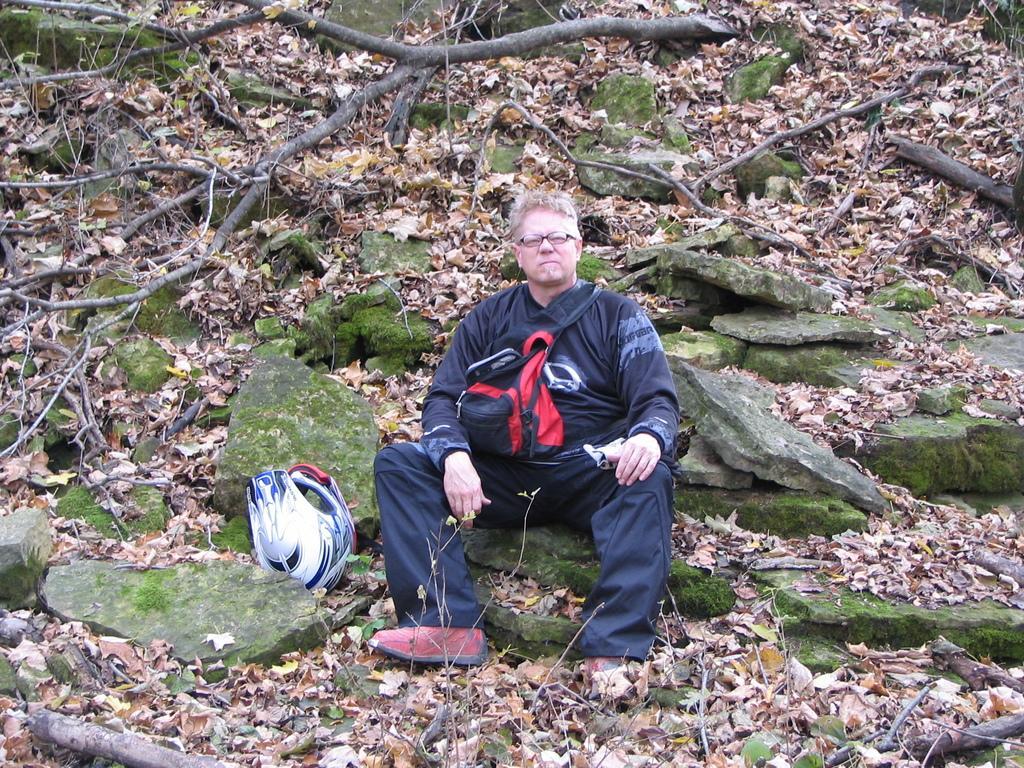Could you give a brief overview of what you see in this image? In the center of the image we can see person sitting on the stone. In the background we can see stones, leaves and tree. 